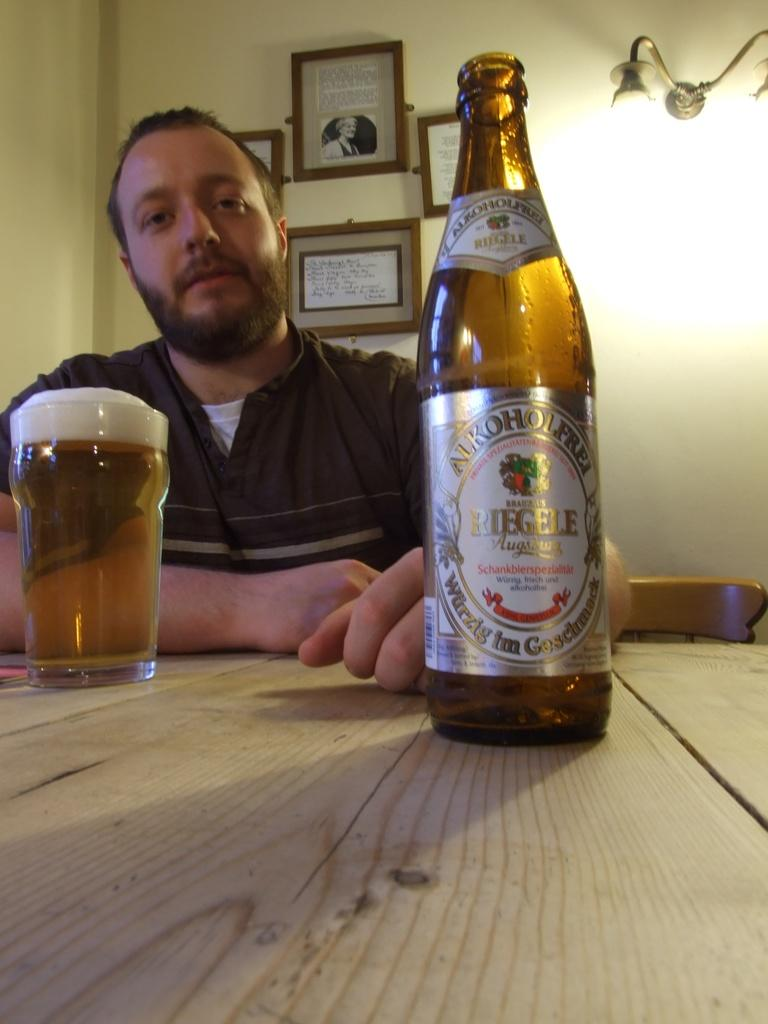Provide a one-sentence caption for the provided image. A man with a glass of beer and a bottle Of Riegel Augustus Alkoholfrei. 